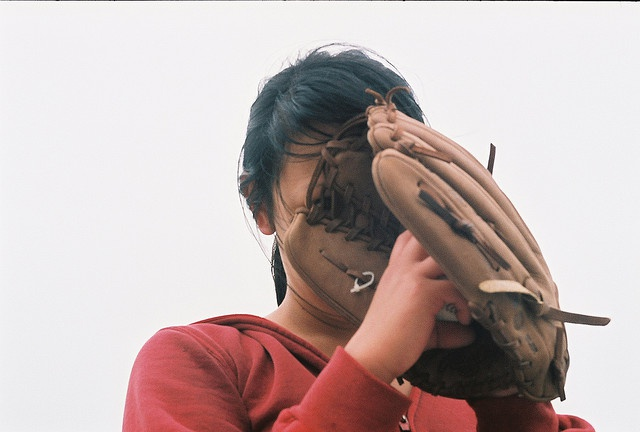Describe the objects in this image and their specific colors. I can see people in darkgray, black, brown, gray, and maroon tones, baseball glove in darkgray, black, gray, and tan tones, and sports ball in darkgray, gray, and black tones in this image. 